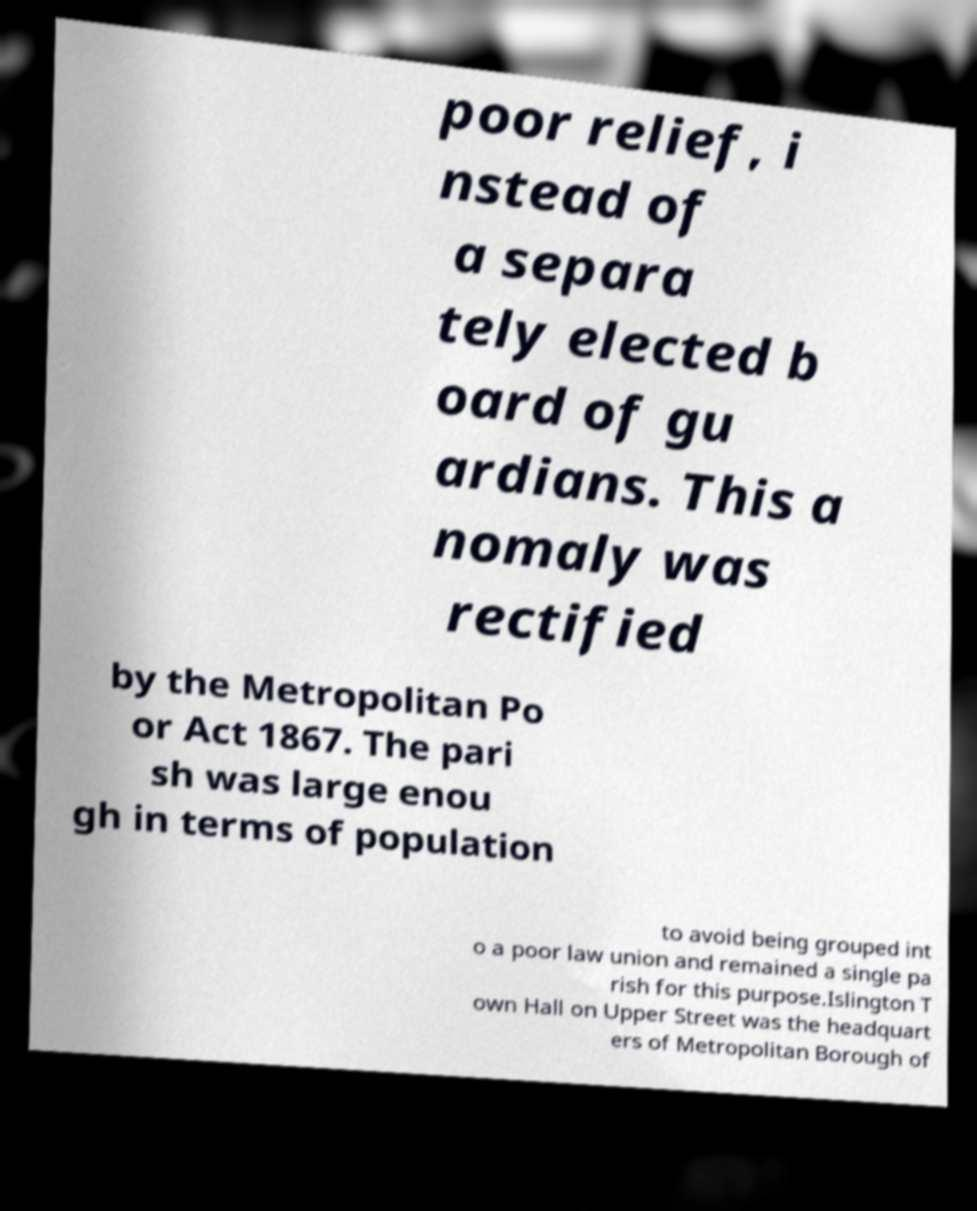I need the written content from this picture converted into text. Can you do that? poor relief, i nstead of a separa tely elected b oard of gu ardians. This a nomaly was rectified by the Metropolitan Po or Act 1867. The pari sh was large enou gh in terms of population to avoid being grouped int o a poor law union and remained a single pa rish for this purpose.Islington T own Hall on Upper Street was the headquart ers of Metropolitan Borough of 